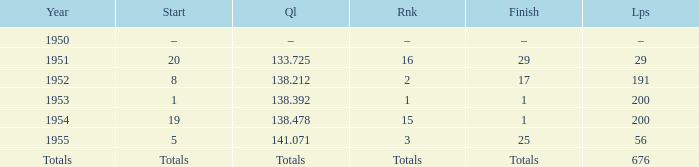Parse the full table. {'header': ['Year', 'Start', 'Ql', 'Rnk', 'Finish', 'Lps'], 'rows': [['1950', '–', '–', '–', '–', '–'], ['1951', '20', '133.725', '16', '29', '29'], ['1952', '8', '138.212', '2', '17', '191'], ['1953', '1', '138.392', '1', '1', '200'], ['1954', '19', '138.478', '15', '1', '200'], ['1955', '5', '141.071', '3', '25', '56'], ['Totals', 'Totals', 'Totals', 'Totals', 'Totals', '676']]} How many laps does the one ranked 16 have? 29.0. 